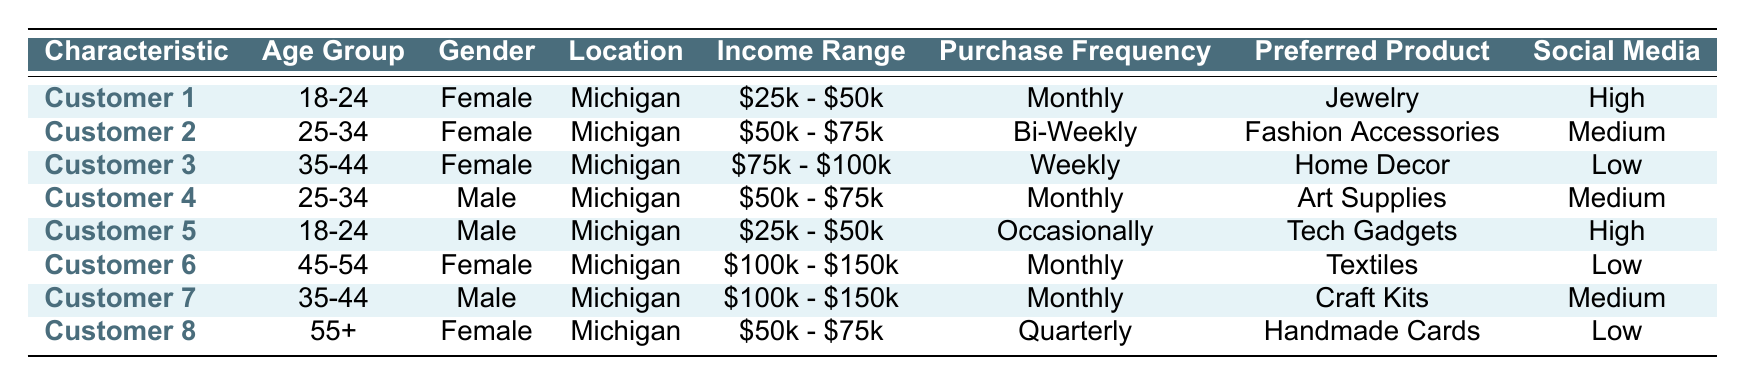What is the preferred product type for Customer 3? Customer 3 falls in the age group 35-44, is female, and the preferred product type is listed in the table. Referring to Customer 3's information, the preferred product type is Home Decor.
Answer: Home Decor How many female customers are in the table? Looking at the data, there are four female customers: Customer 1, Customer 2, Customer 3, and Customer 6.
Answer: 4 What is the purchase frequency for Customer 5? According to the table, Customer 5 falls in the age group 18-24, is male, and the purchase frequency is indicated in the table. The purchase frequency for Customer 5 is Occasionally.
Answer: Occasionally Is there any customer who prefers Tech Gadgets? Checking the information in the table, Customer 5 is specifically noted to prefer Tech Gadgets. Therefore, the answer is yes.
Answer: Yes Which age group has the highest purchase frequency? Reviewing the purchase frequencies: Customers aged 35-44 and 45-54 have a weekly and monthly purchase frequency respectively, while others vary. The highest frequency is weekly, corresponding to the 35-44 age group (Customer 3).
Answer: 35-44 What is the average income range for the male customers? There are three male customers: Customer 4, Customer 5, and Customer 7 with incomes of $50,000 - $75,000, $25,000 - $50,000, and $100,000 - $150,000 respectively. Since income ranges are not numeric, we take the midpoints for calculation: 62,500, 37,500, and 125,000. The average is (62,500 + 37,500 + 125,000) / 3 = 75,000.
Answer: $75,000 What percentage of customers prefer jewelry? In the table, only Customer 1 prefers jewelry out of 8 total customers, leading to the calculation: (1/8) * 100 = 12.5%.
Answer: 12.5% Are there any customers whose preferred product type is Handmade Cards? According to the table, Customer 8 has Handmade Cards as their preferred product type, confirming that there is indeed a customer who prefers this.
Answer: Yes What is the most common gender among customers who have high social media influence? From the table, Customers 1 and 5 are listed as having high social media influence. Both customers are male and female respectively, thus indicating no single gender is more common. Therefore, both genders are equally represented.
Answer: Both genders What is the income range of the customer in the 55+ age group? Referring to Customer 8, who is aged 55+, her income range is specified in the table. The income range for Customer 8 is $50,000 - $75,000.
Answer: $50,000 - $75,000 How many customers purchase on a monthly basis? Looking at the purchase frequencies, Customers 1, 2, 4, 6, and 7 are noted for making purchases monthly. Therefore, there are five customers who purchase on a monthly basis.
Answer: 5 